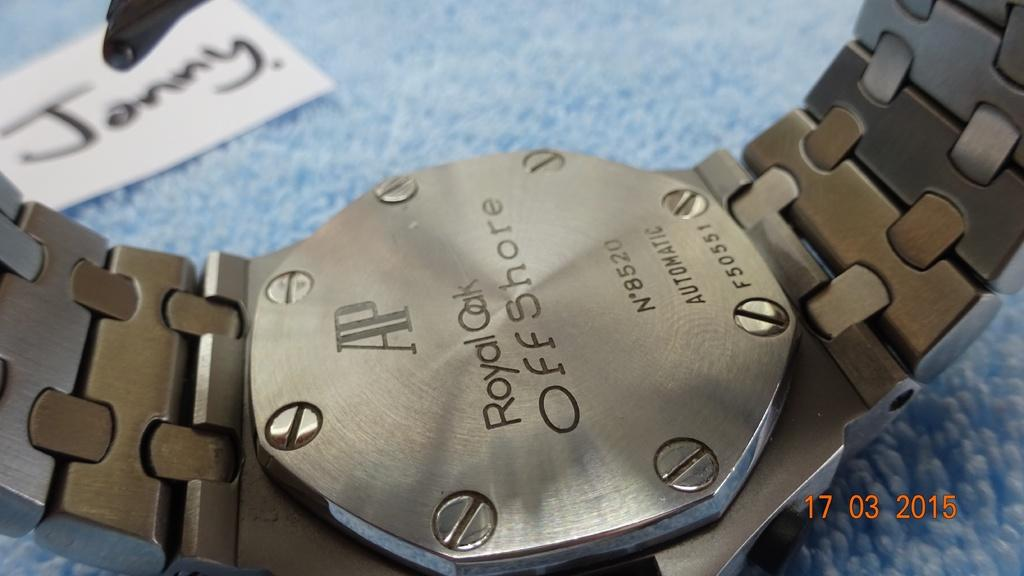<image>
Summarize the visual content of the image. A watch face down, the words Royal Oak are visible. 